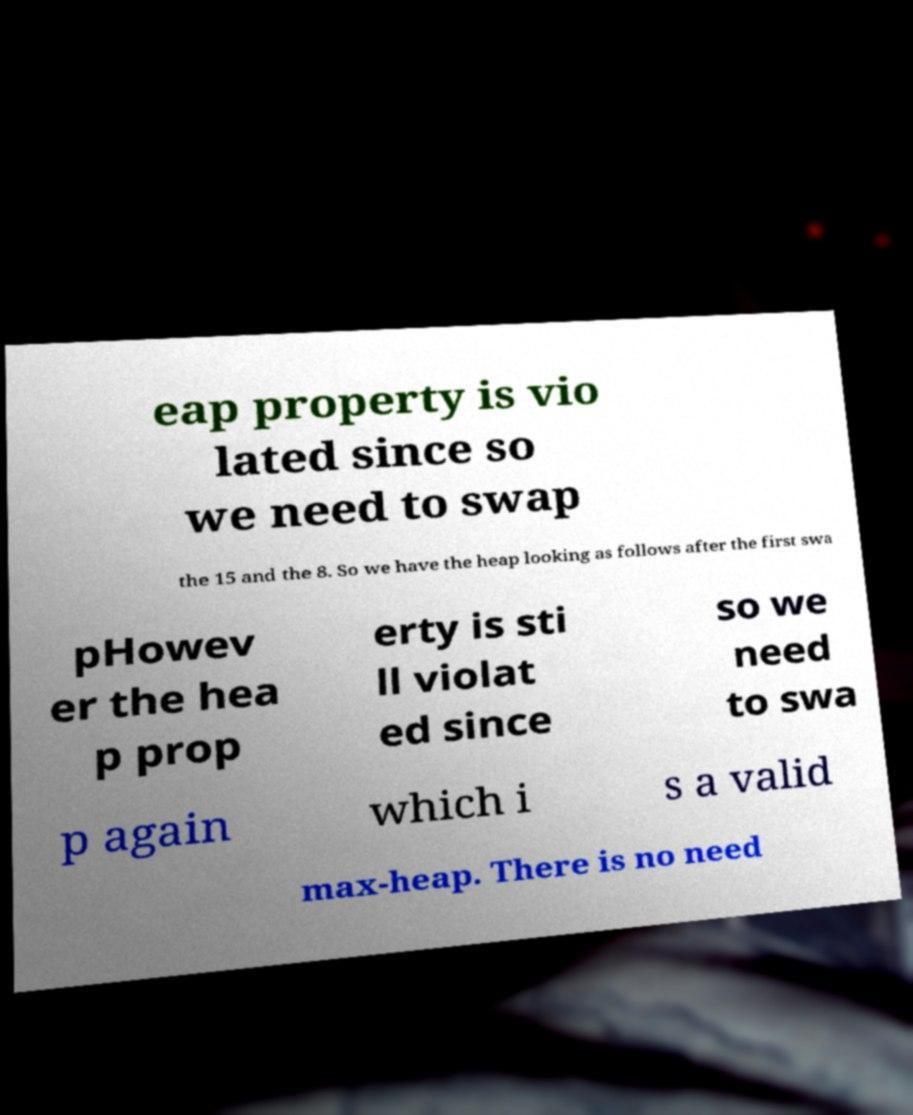I need the written content from this picture converted into text. Can you do that? eap property is vio lated since so we need to swap the 15 and the 8. So we have the heap looking as follows after the first swa pHowev er the hea p prop erty is sti ll violat ed since so we need to swa p again which i s a valid max-heap. There is no need 